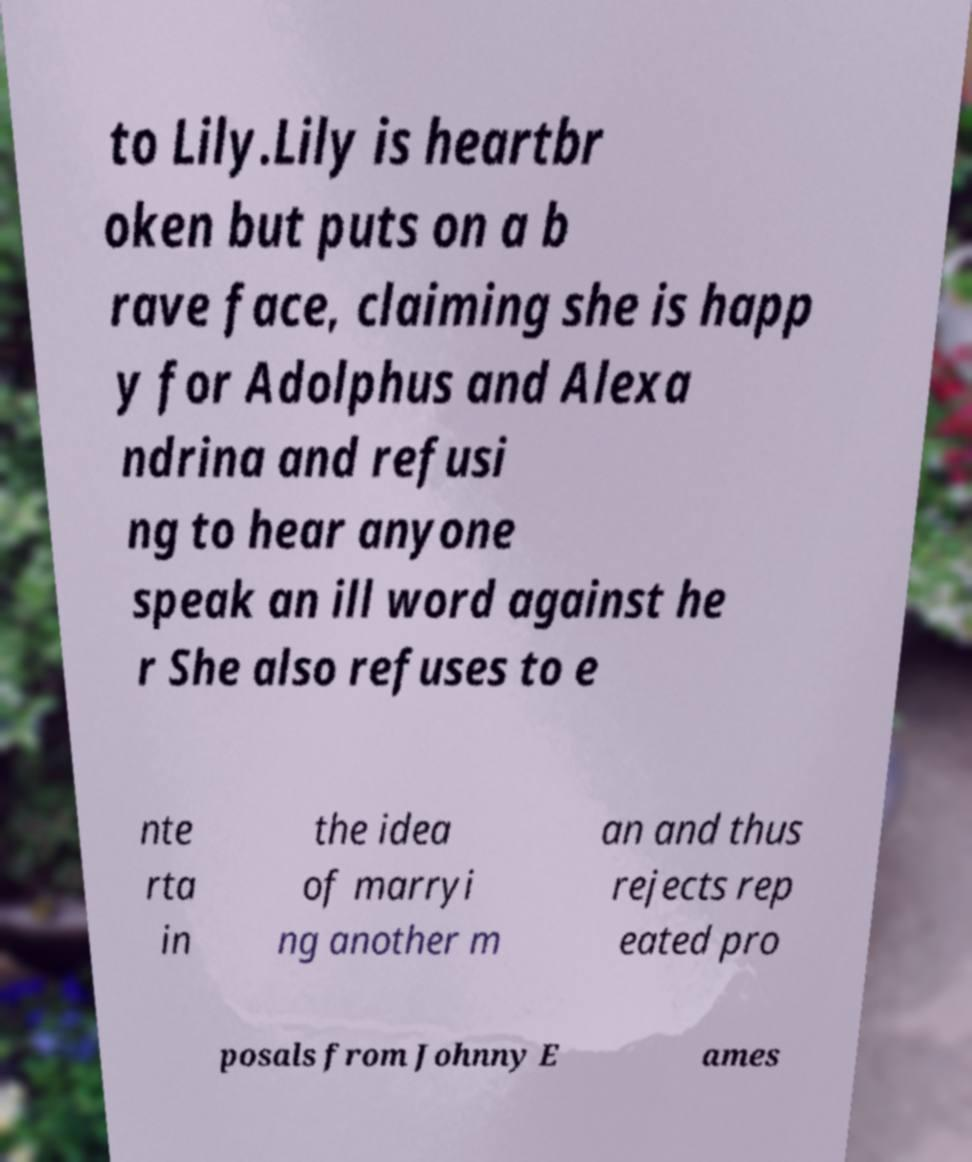Please identify and transcribe the text found in this image. to Lily.Lily is heartbr oken but puts on a b rave face, claiming she is happ y for Adolphus and Alexa ndrina and refusi ng to hear anyone speak an ill word against he r She also refuses to e nte rta in the idea of marryi ng another m an and thus rejects rep eated pro posals from Johnny E ames 